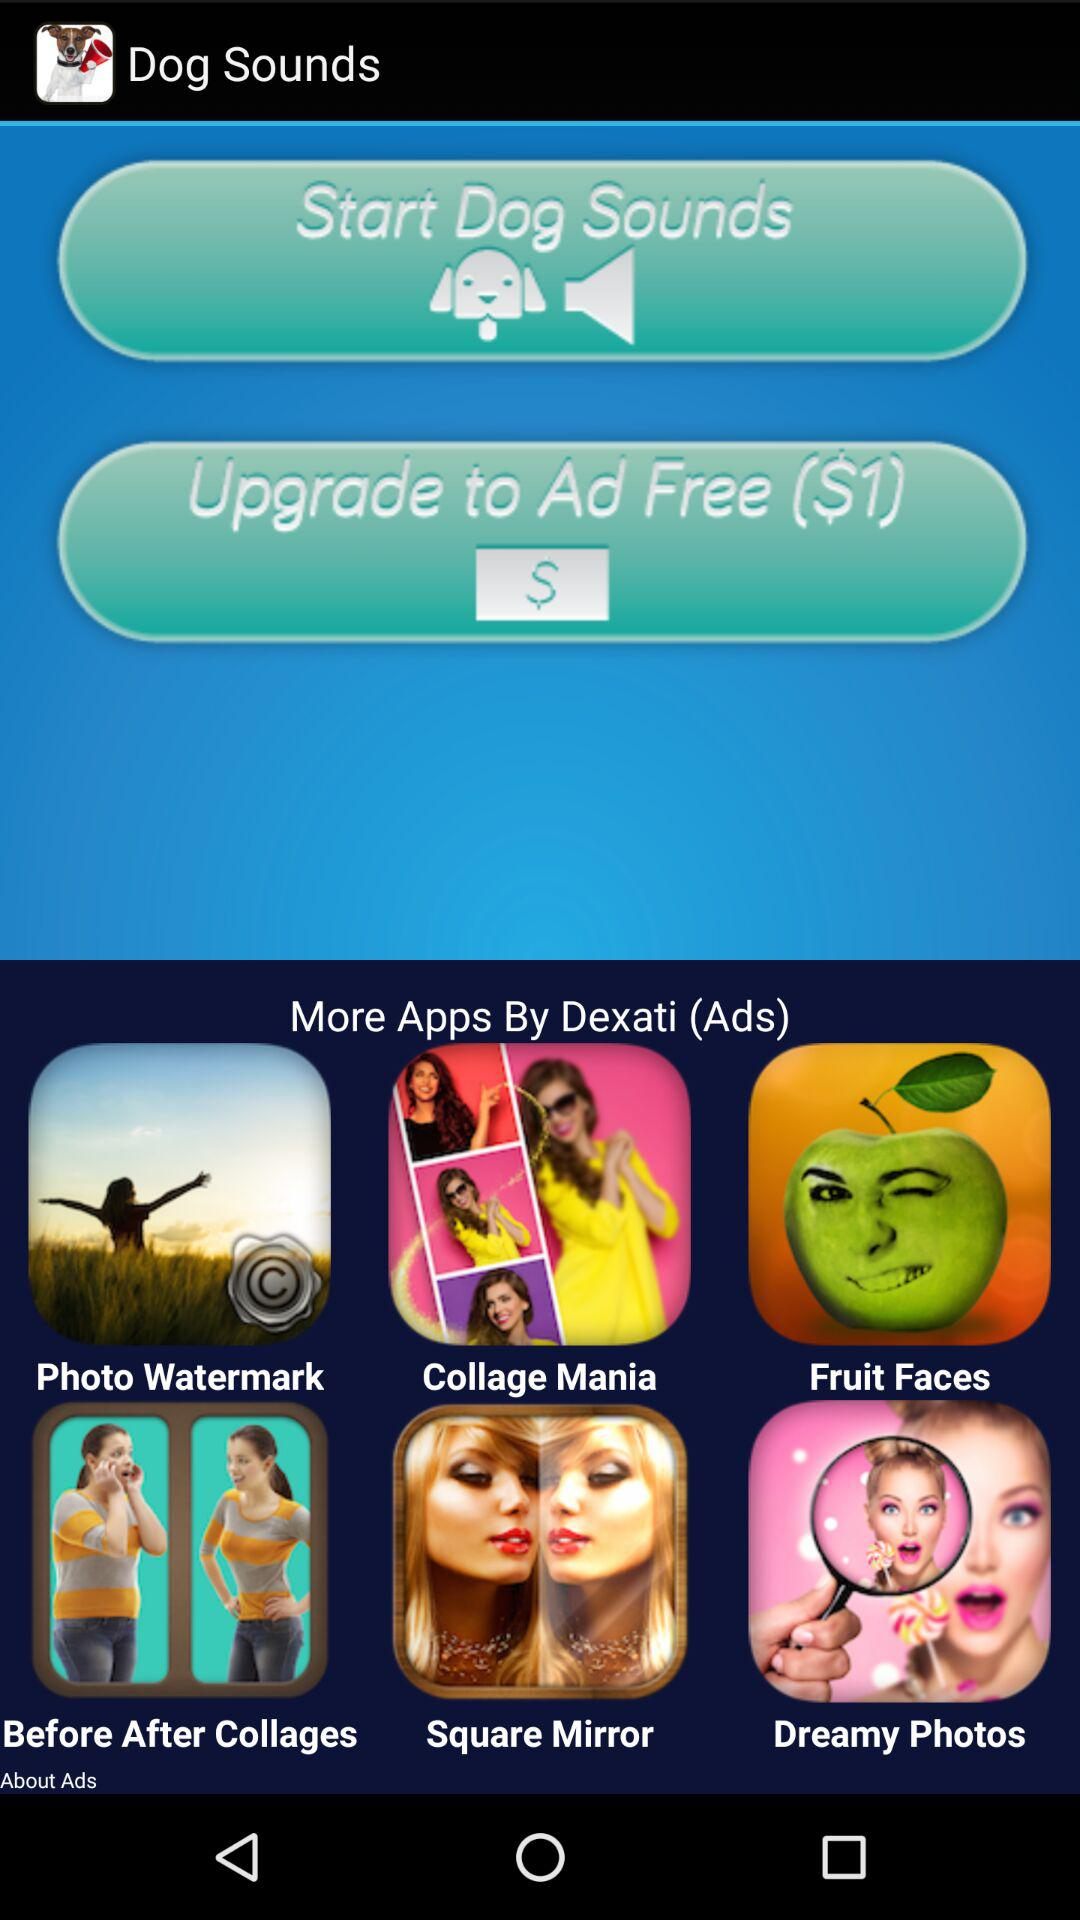What is the price for upgrading to the ad-free version? The price for upgrading to the ad-free version is $1. 